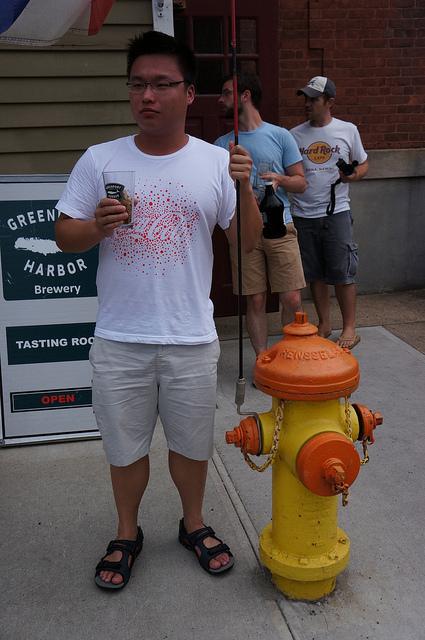What is the man standing in front of?
Concise answer only. Sign. What is the man holding in the left hand?
Short answer required. Pole. Is the Brewery closed?
Keep it brief. No. 